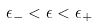Convert formula to latex. <formula><loc_0><loc_0><loc_500><loc_500>\, \epsilon _ { - } < \epsilon < \epsilon _ { + } \,</formula> 